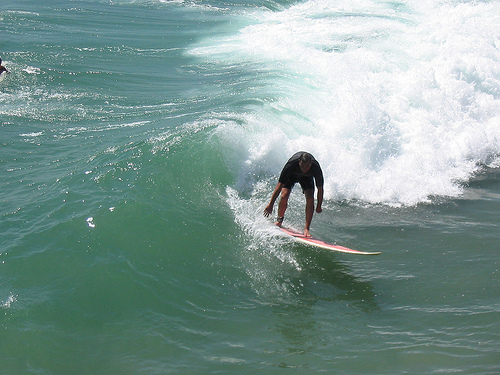Describe the waves in the background. The waves in the background are dynamic and powerful, rolling towards the shore with significant energy. They add to the dynamic atmosphere of the scene, suggesting that the ocean conditions are perfect for surfing, with multiple waves forming and breaking consistently. Can you describe a possible scenario where this image could be taken? This image could have been taken during a surf competition or a training session in a popular surfing location. The clear ocean and well-formed waves suggest ideal surfing conditions. The presence of the surfer in action with a focused expression hints at either a competition or a serious practice session, possibly on a renowned beach known for its excellent wave conditions. 